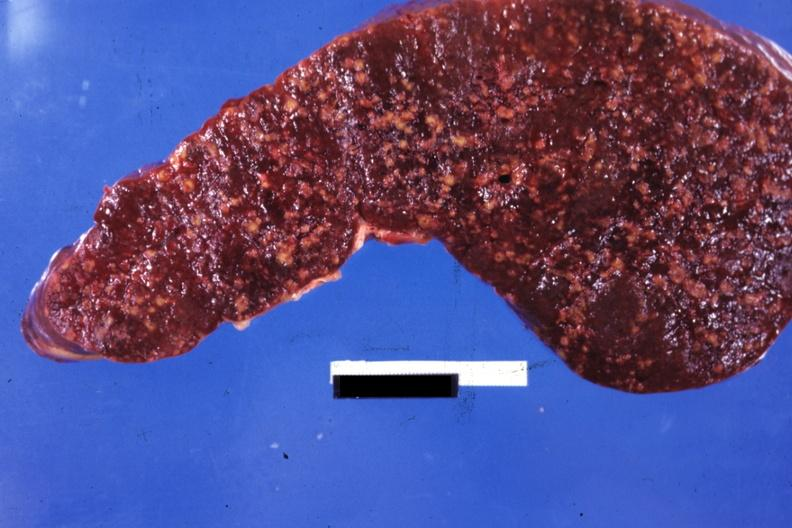does this image show cut surface multiple nodular lesions?
Answer the question using a single word or phrase. Yes 